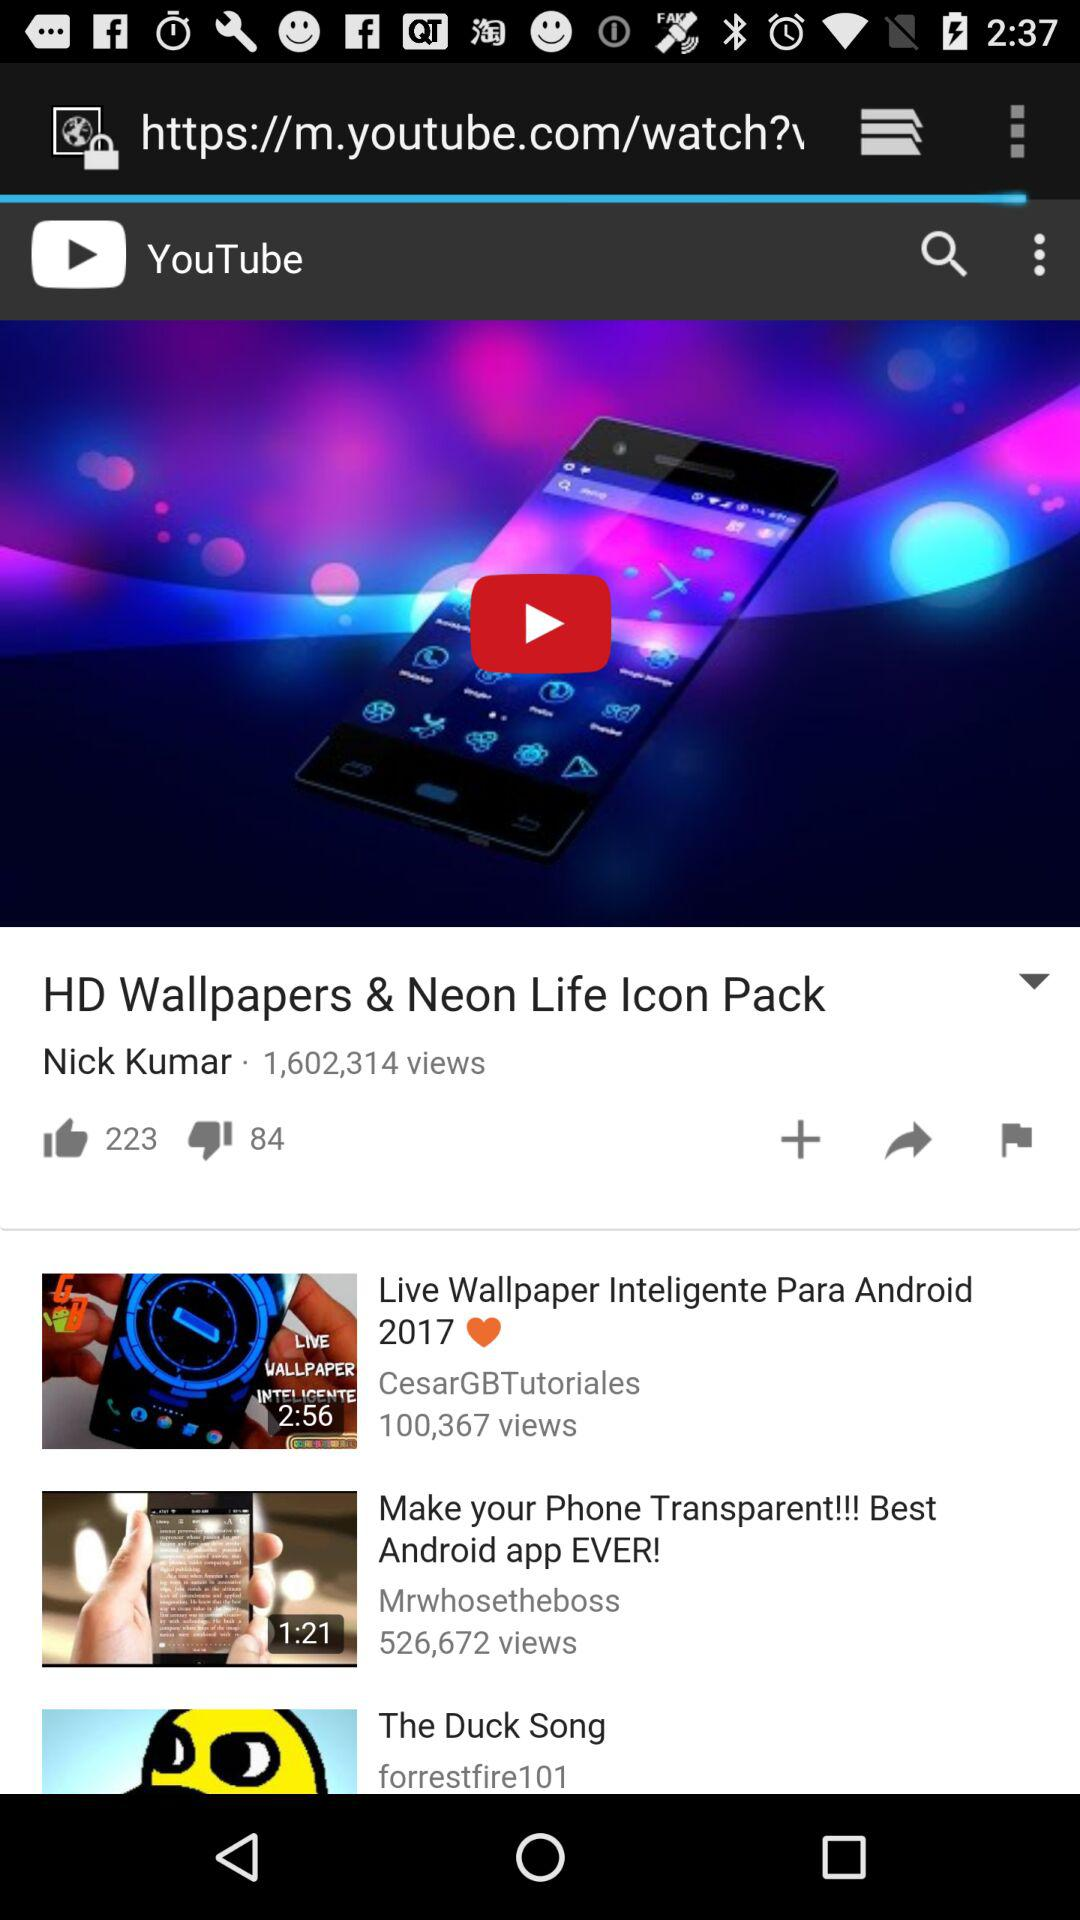How many views are there on "HD Wallpapers & Neon Life Icon Pack"? There are 1,602,314 views. 